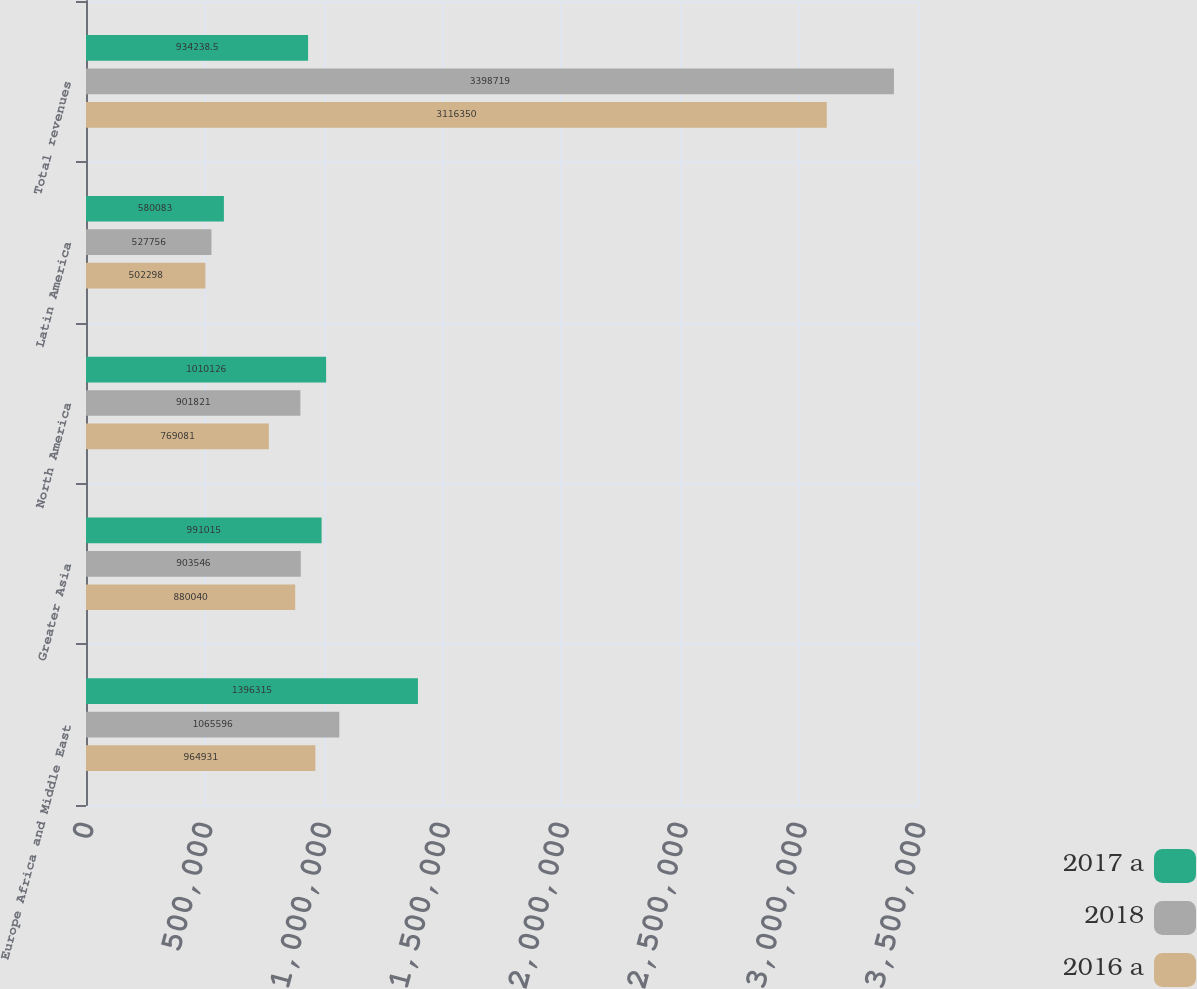<chart> <loc_0><loc_0><loc_500><loc_500><stacked_bar_chart><ecel><fcel>Europe Africa and Middle East<fcel>Greater Asia<fcel>North America<fcel>Latin America<fcel>Total revenues<nl><fcel>2017 a<fcel>1.39632e+06<fcel>991015<fcel>1.01013e+06<fcel>580083<fcel>934238<nl><fcel>2018<fcel>1.0656e+06<fcel>903546<fcel>901821<fcel>527756<fcel>3.39872e+06<nl><fcel>2016 a<fcel>964931<fcel>880040<fcel>769081<fcel>502298<fcel>3.11635e+06<nl></chart> 